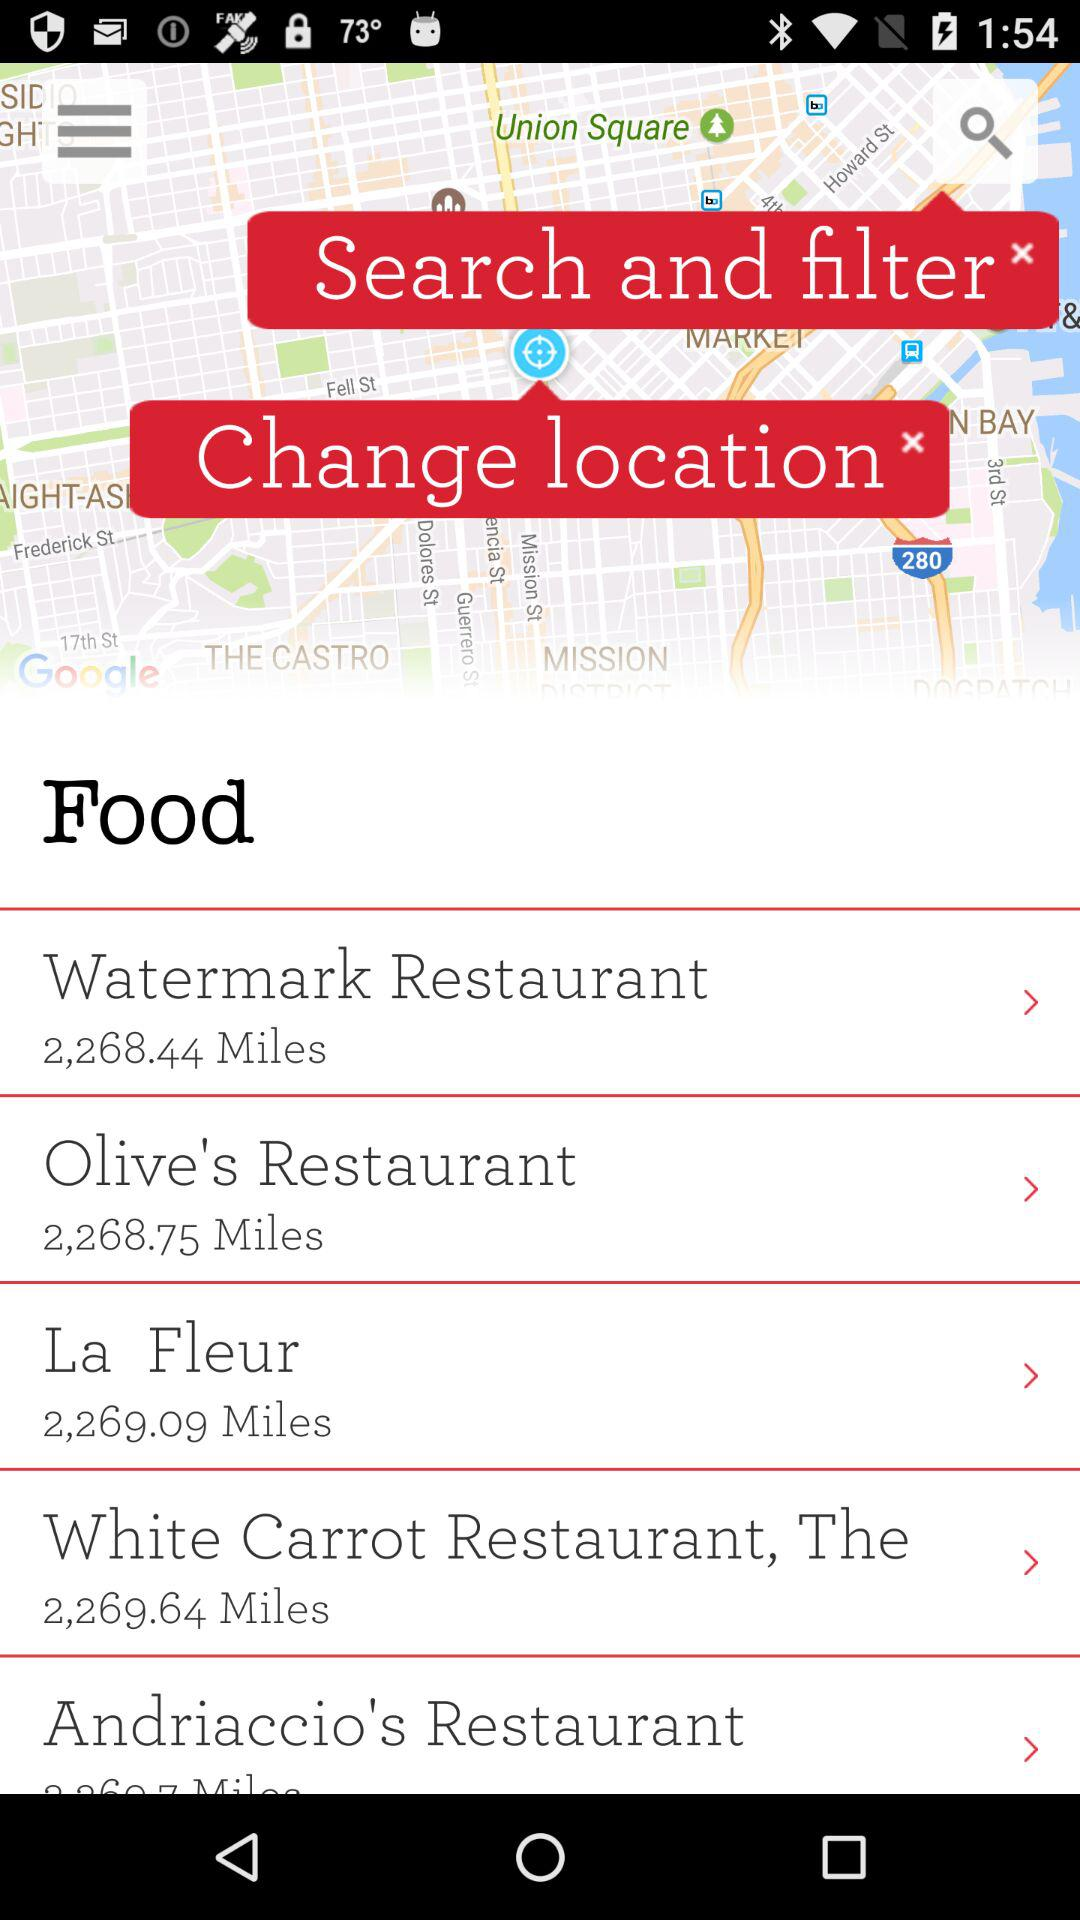For which location is the distance 2,269.09 miles given? The location is "La Fleur". 